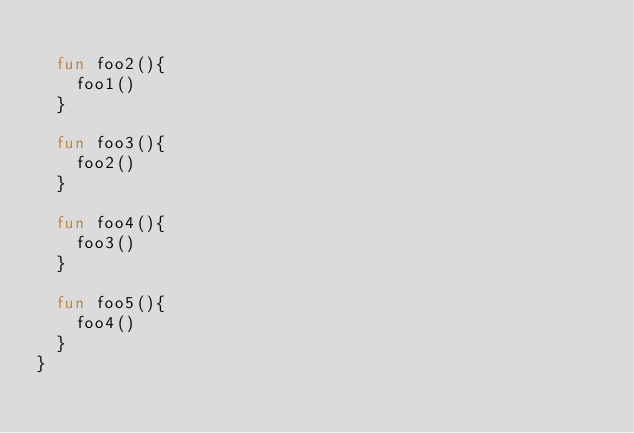Convert code to text. <code><loc_0><loc_0><loc_500><loc_500><_Kotlin_>
  fun foo2(){
    foo1()
  }

  fun foo3(){
    foo2()
  }

  fun foo4(){
    foo3()
  }

  fun foo5(){
    foo4()
  }
}</code> 